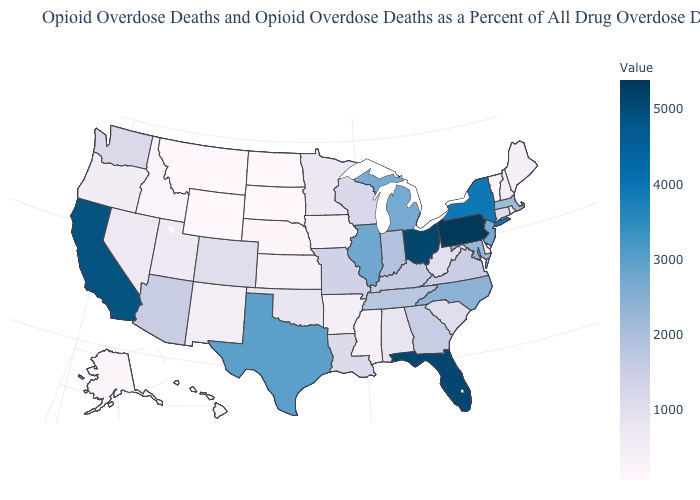Which states have the highest value in the USA?
Write a very short answer. Pennsylvania. Does Oregon have the lowest value in the West?
Give a very brief answer. No. 